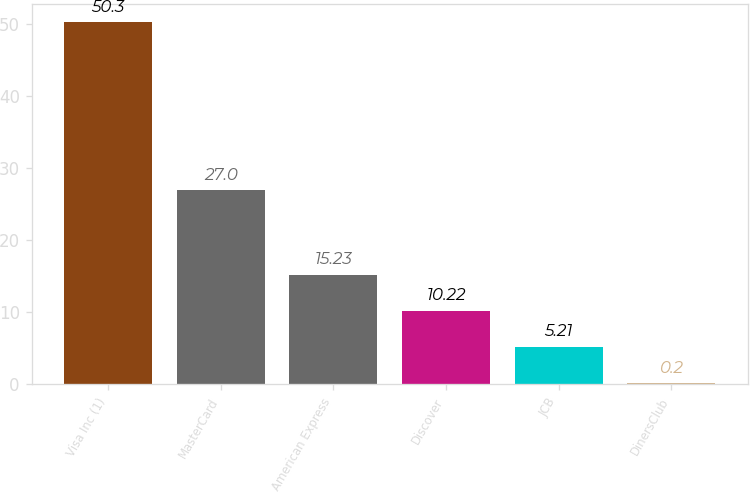<chart> <loc_0><loc_0><loc_500><loc_500><bar_chart><fcel>Visa Inc (1)<fcel>MasterCard<fcel>American Express<fcel>Discover<fcel>JCB<fcel>DinersClub<nl><fcel>50.3<fcel>27<fcel>15.23<fcel>10.22<fcel>5.21<fcel>0.2<nl></chart> 